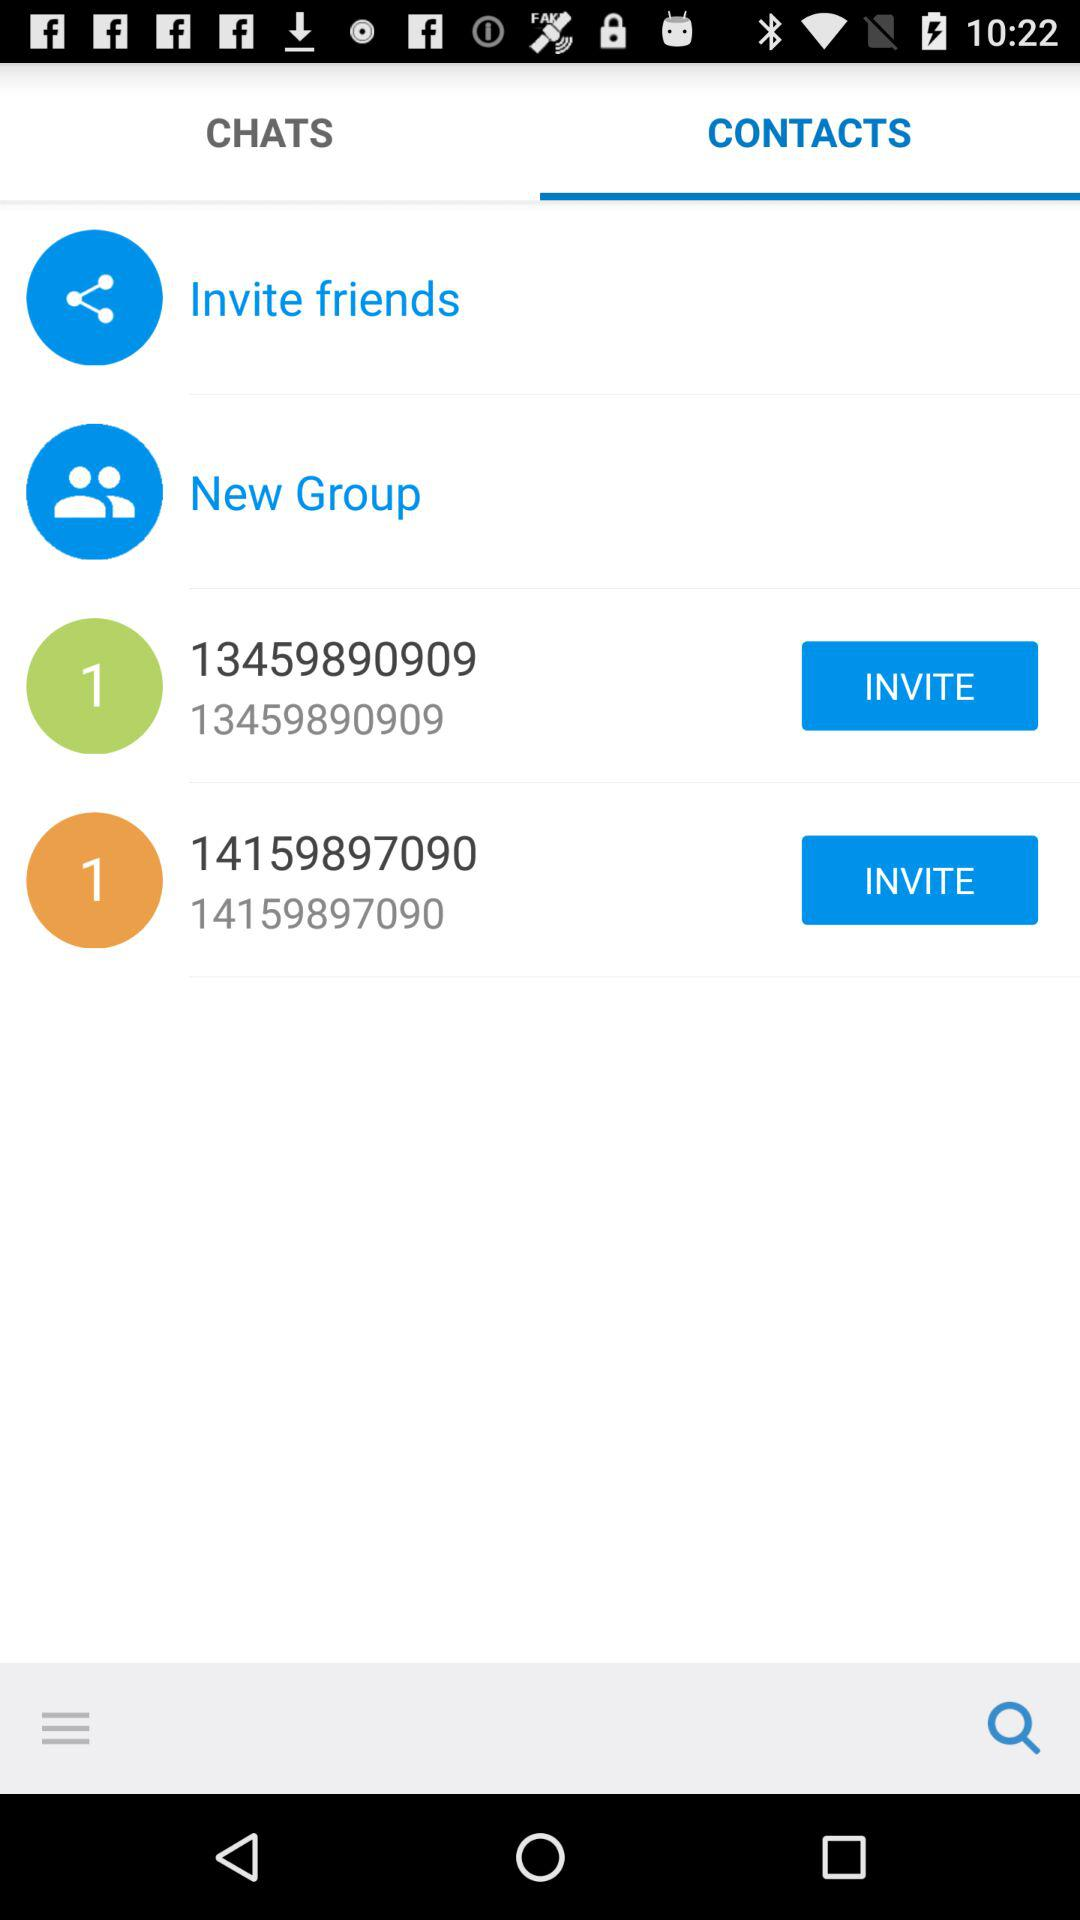What are the phone numbers? The phone numbers are 13459890909 and 14159897090. 